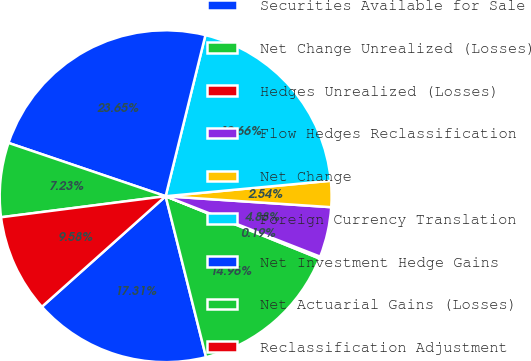<chart> <loc_0><loc_0><loc_500><loc_500><pie_chart><fcel>Securities Available for Sale<fcel>Net Change Unrealized (Losses)<fcel>Hedges Unrealized (Losses)<fcel>Flow Hedges Reclassification<fcel>Net Change<fcel>Foreign Currency Translation<fcel>Net Investment Hedge Gains<fcel>Net Actuarial Gains (Losses)<fcel>Reclassification Adjustment<nl><fcel>17.31%<fcel>14.96%<fcel>0.19%<fcel>4.88%<fcel>2.54%<fcel>19.66%<fcel>23.65%<fcel>7.23%<fcel>9.58%<nl></chart> 